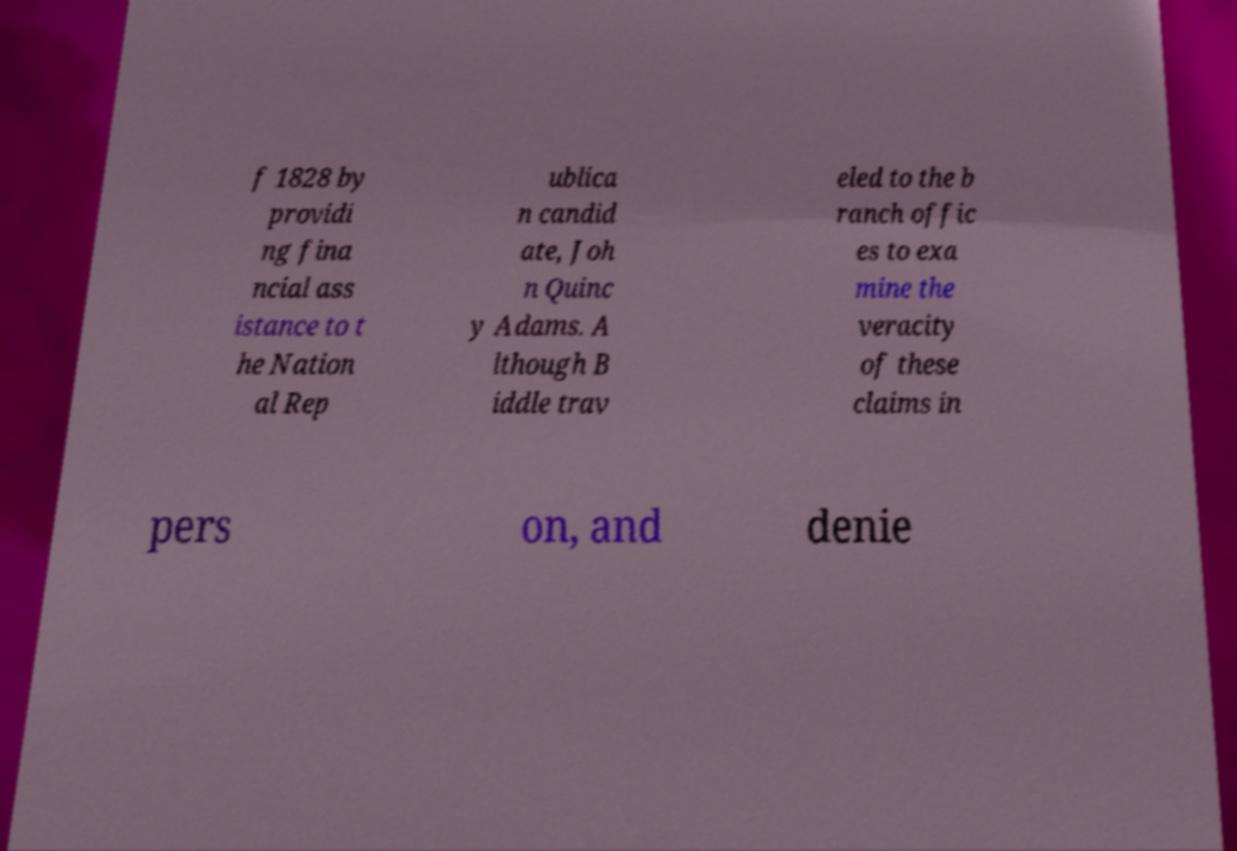There's text embedded in this image that I need extracted. Can you transcribe it verbatim? f 1828 by providi ng fina ncial ass istance to t he Nation al Rep ublica n candid ate, Joh n Quinc y Adams. A lthough B iddle trav eled to the b ranch offic es to exa mine the veracity of these claims in pers on, and denie 